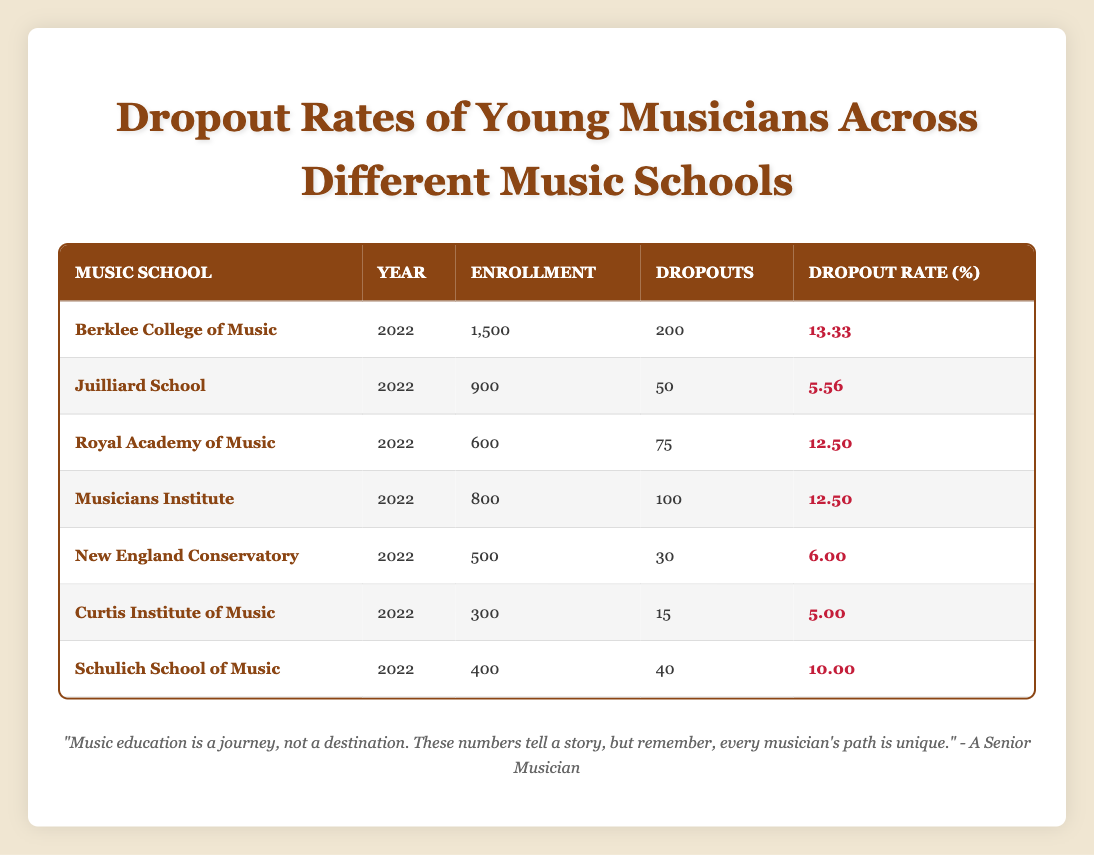What is the dropout rate for Juilliard School? According to the table, the dropout rate for Juilliard School in 2022 is listed as 5.56%.
Answer: 5.56 Which music school had the highest enrollment? By comparing the enrollment numbers, Berklee College of Music, with an enrollment of 1500, had the highest enrollment among the listed schools.
Answer: Berklee College of Music What is the total number of dropouts from all music schools combined? Adding the number of dropouts from each school: 200 (Berklee) + 50 (Juilliard) + 75 (Royal Academy) + 100 (Musicians Institute) + 30 (New England Conservatory) + 15 (Curtis) + 40 (Schulich) = 610.
Answer: 610 Is the dropout rate for Curtis Institute of Music higher than that of New England Conservatory? The dropout rate for Curtis Institute is 5.00%, whereas for New England Conservatory it is 6.00%. Therefore, Curtis has a lower dropout rate.
Answer: No What is the average dropout rate across all the specified music schools? To find the average dropout rate, sum the dropout rates: 13.33 + 5.56 + 12.50 + 12.50 + 6.00 + 5.00 + 10.00 = 64.89. There are 7 schools, so the average is 64.89 / 7 ≈ 9.27.
Answer: 9.27 Which school had a dropout rate of 12.50%? Both Royal Academy of Music and Musicians Institute have a dropout rate of 12.50% as stated in the table.
Answer: Royal Academy of Music and Musicians Institute What percentage of students dropped out or left their studies at New England Conservatory? The dropout rate at New England Conservatory is given as 6.00%.
Answer: 6.00 Compare the dropout rates of the two schools with the lowest enrollment. Which one has the lower dropout rate? The two schools with the lowest enrollment are Curtis Institute of Music (300) and New England Conservatory (500); their dropout rates are 5.00% and 6.00%, respectively. Curtis Institute has the lower rate at 5.00%.
Answer: Curtis Institute of Music 